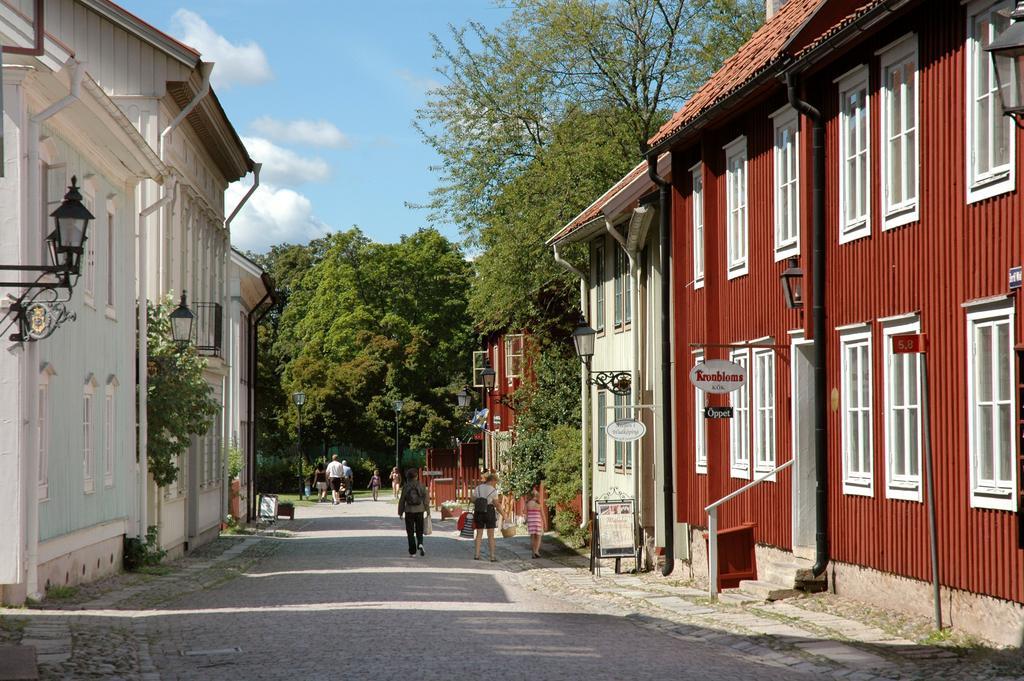How would you summarize this image in a sentence or two? In this image I can see few buildings,windows,light-poles,signboards,trees and few people are wearing bags and walking on the road. The sky is in blue and white color. 